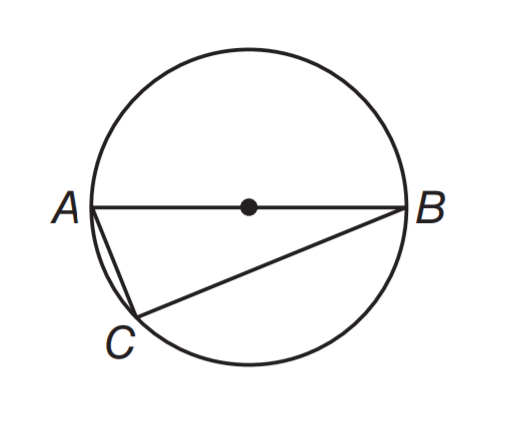Answer the mathemtical geometry problem and directly provide the correct option letter.
Question: A B is a diameter, A C = 8 inches, and B C = 15 inches. Find the diameter of the circle.
Choices: A: 8 B: 8.5 C: 15 D: 17 D 